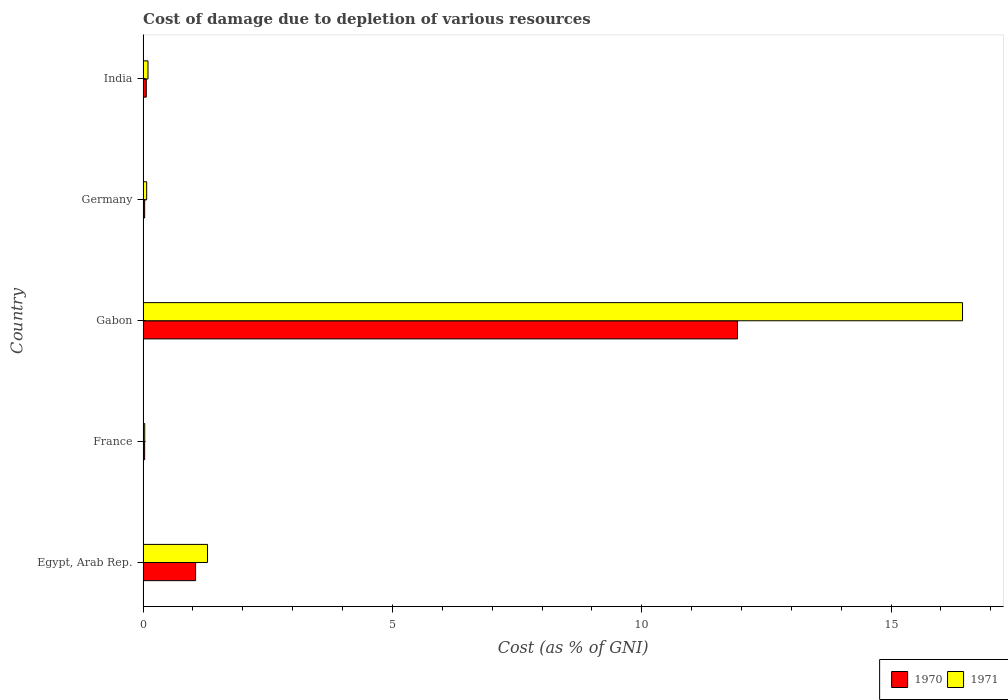How many groups of bars are there?
Give a very brief answer. 5. Are the number of bars per tick equal to the number of legend labels?
Your answer should be very brief. Yes. Are the number of bars on each tick of the Y-axis equal?
Your answer should be very brief. Yes. How many bars are there on the 3rd tick from the top?
Your answer should be compact. 2. How many bars are there on the 5th tick from the bottom?
Your response must be concise. 2. What is the label of the 3rd group of bars from the top?
Make the answer very short. Gabon. What is the cost of damage caused due to the depletion of various resources in 1971 in India?
Your answer should be compact. 0.1. Across all countries, what is the maximum cost of damage caused due to the depletion of various resources in 1971?
Your answer should be very brief. 16.43. Across all countries, what is the minimum cost of damage caused due to the depletion of various resources in 1971?
Ensure brevity in your answer.  0.03. In which country was the cost of damage caused due to the depletion of various resources in 1971 maximum?
Your answer should be very brief. Gabon. What is the total cost of damage caused due to the depletion of various resources in 1971 in the graph?
Keep it short and to the point. 17.93. What is the difference between the cost of damage caused due to the depletion of various resources in 1970 in Egypt, Arab Rep. and that in Germany?
Your answer should be compact. 1.02. What is the difference between the cost of damage caused due to the depletion of various resources in 1971 in Germany and the cost of damage caused due to the depletion of various resources in 1970 in France?
Provide a succinct answer. 0.04. What is the average cost of damage caused due to the depletion of various resources in 1971 per country?
Make the answer very short. 3.59. What is the difference between the cost of damage caused due to the depletion of various resources in 1971 and cost of damage caused due to the depletion of various resources in 1970 in Gabon?
Your answer should be very brief. 4.51. In how many countries, is the cost of damage caused due to the depletion of various resources in 1970 greater than 9 %?
Give a very brief answer. 1. What is the ratio of the cost of damage caused due to the depletion of various resources in 1970 in Egypt, Arab Rep. to that in Gabon?
Provide a short and direct response. 0.09. Is the difference between the cost of damage caused due to the depletion of various resources in 1971 in Egypt, Arab Rep. and Gabon greater than the difference between the cost of damage caused due to the depletion of various resources in 1970 in Egypt, Arab Rep. and Gabon?
Give a very brief answer. No. What is the difference between the highest and the second highest cost of damage caused due to the depletion of various resources in 1970?
Keep it short and to the point. 10.87. What is the difference between the highest and the lowest cost of damage caused due to the depletion of various resources in 1970?
Your answer should be very brief. 11.89. In how many countries, is the cost of damage caused due to the depletion of various resources in 1970 greater than the average cost of damage caused due to the depletion of various resources in 1970 taken over all countries?
Offer a terse response. 1. Is the sum of the cost of damage caused due to the depletion of various resources in 1971 in Germany and India greater than the maximum cost of damage caused due to the depletion of various resources in 1970 across all countries?
Offer a very short reply. No. Are all the bars in the graph horizontal?
Provide a short and direct response. Yes. What is the difference between two consecutive major ticks on the X-axis?
Provide a short and direct response. 5. Are the values on the major ticks of X-axis written in scientific E-notation?
Your answer should be compact. No. Where does the legend appear in the graph?
Provide a succinct answer. Bottom right. How are the legend labels stacked?
Ensure brevity in your answer.  Horizontal. What is the title of the graph?
Your response must be concise. Cost of damage due to depletion of various resources. What is the label or title of the X-axis?
Give a very brief answer. Cost (as % of GNI). What is the Cost (as % of GNI) in 1970 in Egypt, Arab Rep.?
Provide a short and direct response. 1.05. What is the Cost (as % of GNI) in 1971 in Egypt, Arab Rep.?
Give a very brief answer. 1.29. What is the Cost (as % of GNI) of 1970 in France?
Offer a terse response. 0.03. What is the Cost (as % of GNI) in 1971 in France?
Your answer should be compact. 0.03. What is the Cost (as % of GNI) of 1970 in Gabon?
Ensure brevity in your answer.  11.92. What is the Cost (as % of GNI) in 1971 in Gabon?
Provide a short and direct response. 16.43. What is the Cost (as % of GNI) of 1970 in Germany?
Provide a short and direct response. 0.03. What is the Cost (as % of GNI) of 1971 in Germany?
Your response must be concise. 0.07. What is the Cost (as % of GNI) of 1970 in India?
Provide a succinct answer. 0.06. What is the Cost (as % of GNI) of 1971 in India?
Your answer should be very brief. 0.1. Across all countries, what is the maximum Cost (as % of GNI) in 1970?
Provide a succinct answer. 11.92. Across all countries, what is the maximum Cost (as % of GNI) in 1971?
Offer a terse response. 16.43. Across all countries, what is the minimum Cost (as % of GNI) of 1970?
Ensure brevity in your answer.  0.03. Across all countries, what is the minimum Cost (as % of GNI) of 1971?
Offer a terse response. 0.03. What is the total Cost (as % of GNI) in 1970 in the graph?
Offer a terse response. 13.1. What is the total Cost (as % of GNI) of 1971 in the graph?
Offer a very short reply. 17.93. What is the difference between the Cost (as % of GNI) in 1970 in Egypt, Arab Rep. and that in France?
Offer a very short reply. 1.02. What is the difference between the Cost (as % of GNI) in 1971 in Egypt, Arab Rep. and that in France?
Your response must be concise. 1.26. What is the difference between the Cost (as % of GNI) of 1970 in Egypt, Arab Rep. and that in Gabon?
Your answer should be very brief. -10.87. What is the difference between the Cost (as % of GNI) in 1971 in Egypt, Arab Rep. and that in Gabon?
Make the answer very short. -15.14. What is the difference between the Cost (as % of GNI) of 1970 in Egypt, Arab Rep. and that in Germany?
Offer a terse response. 1.02. What is the difference between the Cost (as % of GNI) of 1971 in Egypt, Arab Rep. and that in Germany?
Your response must be concise. 1.22. What is the difference between the Cost (as % of GNI) in 1970 in Egypt, Arab Rep. and that in India?
Keep it short and to the point. 0.99. What is the difference between the Cost (as % of GNI) of 1971 in Egypt, Arab Rep. and that in India?
Keep it short and to the point. 1.19. What is the difference between the Cost (as % of GNI) in 1970 in France and that in Gabon?
Ensure brevity in your answer.  -11.89. What is the difference between the Cost (as % of GNI) of 1971 in France and that in Gabon?
Ensure brevity in your answer.  -16.4. What is the difference between the Cost (as % of GNI) in 1970 in France and that in Germany?
Offer a very short reply. -0. What is the difference between the Cost (as % of GNI) of 1971 in France and that in Germany?
Your answer should be very brief. -0.04. What is the difference between the Cost (as % of GNI) of 1970 in France and that in India?
Your response must be concise. -0.03. What is the difference between the Cost (as % of GNI) of 1971 in France and that in India?
Offer a terse response. -0.07. What is the difference between the Cost (as % of GNI) of 1970 in Gabon and that in Germany?
Keep it short and to the point. 11.89. What is the difference between the Cost (as % of GNI) in 1971 in Gabon and that in Germany?
Offer a very short reply. 16.36. What is the difference between the Cost (as % of GNI) of 1970 in Gabon and that in India?
Provide a short and direct response. 11.86. What is the difference between the Cost (as % of GNI) in 1971 in Gabon and that in India?
Offer a terse response. 16.33. What is the difference between the Cost (as % of GNI) of 1970 in Germany and that in India?
Your answer should be compact. -0.03. What is the difference between the Cost (as % of GNI) of 1971 in Germany and that in India?
Offer a very short reply. -0.03. What is the difference between the Cost (as % of GNI) in 1970 in Egypt, Arab Rep. and the Cost (as % of GNI) in 1971 in France?
Offer a terse response. 1.02. What is the difference between the Cost (as % of GNI) of 1970 in Egypt, Arab Rep. and the Cost (as % of GNI) of 1971 in Gabon?
Make the answer very short. -15.38. What is the difference between the Cost (as % of GNI) in 1970 in Egypt, Arab Rep. and the Cost (as % of GNI) in 1971 in Germany?
Provide a short and direct response. 0.98. What is the difference between the Cost (as % of GNI) of 1970 in Egypt, Arab Rep. and the Cost (as % of GNI) of 1971 in India?
Offer a terse response. 0.95. What is the difference between the Cost (as % of GNI) of 1970 in France and the Cost (as % of GNI) of 1971 in Gabon?
Give a very brief answer. -16.4. What is the difference between the Cost (as % of GNI) of 1970 in France and the Cost (as % of GNI) of 1971 in Germany?
Offer a terse response. -0.04. What is the difference between the Cost (as % of GNI) of 1970 in France and the Cost (as % of GNI) of 1971 in India?
Your answer should be compact. -0.07. What is the difference between the Cost (as % of GNI) of 1970 in Gabon and the Cost (as % of GNI) of 1971 in Germany?
Your answer should be very brief. 11.85. What is the difference between the Cost (as % of GNI) of 1970 in Gabon and the Cost (as % of GNI) of 1971 in India?
Your answer should be very brief. 11.82. What is the difference between the Cost (as % of GNI) of 1970 in Germany and the Cost (as % of GNI) of 1971 in India?
Offer a very short reply. -0.07. What is the average Cost (as % of GNI) in 1970 per country?
Your answer should be compact. 2.62. What is the average Cost (as % of GNI) in 1971 per country?
Offer a terse response. 3.59. What is the difference between the Cost (as % of GNI) of 1970 and Cost (as % of GNI) of 1971 in Egypt, Arab Rep.?
Provide a short and direct response. -0.24. What is the difference between the Cost (as % of GNI) of 1970 and Cost (as % of GNI) of 1971 in France?
Give a very brief answer. -0. What is the difference between the Cost (as % of GNI) in 1970 and Cost (as % of GNI) in 1971 in Gabon?
Your response must be concise. -4.51. What is the difference between the Cost (as % of GNI) of 1970 and Cost (as % of GNI) of 1971 in Germany?
Your answer should be very brief. -0.04. What is the difference between the Cost (as % of GNI) in 1970 and Cost (as % of GNI) in 1971 in India?
Ensure brevity in your answer.  -0.03. What is the ratio of the Cost (as % of GNI) in 1970 in Egypt, Arab Rep. to that in France?
Your answer should be compact. 33.37. What is the ratio of the Cost (as % of GNI) in 1971 in Egypt, Arab Rep. to that in France?
Make the answer very short. 38.77. What is the ratio of the Cost (as % of GNI) of 1970 in Egypt, Arab Rep. to that in Gabon?
Give a very brief answer. 0.09. What is the ratio of the Cost (as % of GNI) in 1971 in Egypt, Arab Rep. to that in Gabon?
Your answer should be compact. 0.08. What is the ratio of the Cost (as % of GNI) in 1970 in Egypt, Arab Rep. to that in Germany?
Your answer should be very brief. 32.93. What is the ratio of the Cost (as % of GNI) in 1971 in Egypt, Arab Rep. to that in Germany?
Offer a very short reply. 17.84. What is the ratio of the Cost (as % of GNI) in 1970 in Egypt, Arab Rep. to that in India?
Make the answer very short. 16.34. What is the ratio of the Cost (as % of GNI) of 1971 in Egypt, Arab Rep. to that in India?
Ensure brevity in your answer.  13.1. What is the ratio of the Cost (as % of GNI) in 1970 in France to that in Gabon?
Make the answer very short. 0. What is the ratio of the Cost (as % of GNI) in 1971 in France to that in Gabon?
Provide a short and direct response. 0. What is the ratio of the Cost (as % of GNI) in 1970 in France to that in Germany?
Your answer should be compact. 0.99. What is the ratio of the Cost (as % of GNI) in 1971 in France to that in Germany?
Offer a terse response. 0.46. What is the ratio of the Cost (as % of GNI) of 1970 in France to that in India?
Your answer should be very brief. 0.49. What is the ratio of the Cost (as % of GNI) of 1971 in France to that in India?
Keep it short and to the point. 0.34. What is the ratio of the Cost (as % of GNI) of 1970 in Gabon to that in Germany?
Keep it short and to the point. 372.66. What is the ratio of the Cost (as % of GNI) in 1971 in Gabon to that in Germany?
Your response must be concise. 226.83. What is the ratio of the Cost (as % of GNI) of 1970 in Gabon to that in India?
Offer a very short reply. 184.89. What is the ratio of the Cost (as % of GNI) in 1971 in Gabon to that in India?
Offer a very short reply. 166.63. What is the ratio of the Cost (as % of GNI) in 1970 in Germany to that in India?
Keep it short and to the point. 0.5. What is the ratio of the Cost (as % of GNI) of 1971 in Germany to that in India?
Keep it short and to the point. 0.73. What is the difference between the highest and the second highest Cost (as % of GNI) of 1970?
Make the answer very short. 10.87. What is the difference between the highest and the second highest Cost (as % of GNI) in 1971?
Make the answer very short. 15.14. What is the difference between the highest and the lowest Cost (as % of GNI) of 1970?
Provide a short and direct response. 11.89. What is the difference between the highest and the lowest Cost (as % of GNI) in 1971?
Your response must be concise. 16.4. 